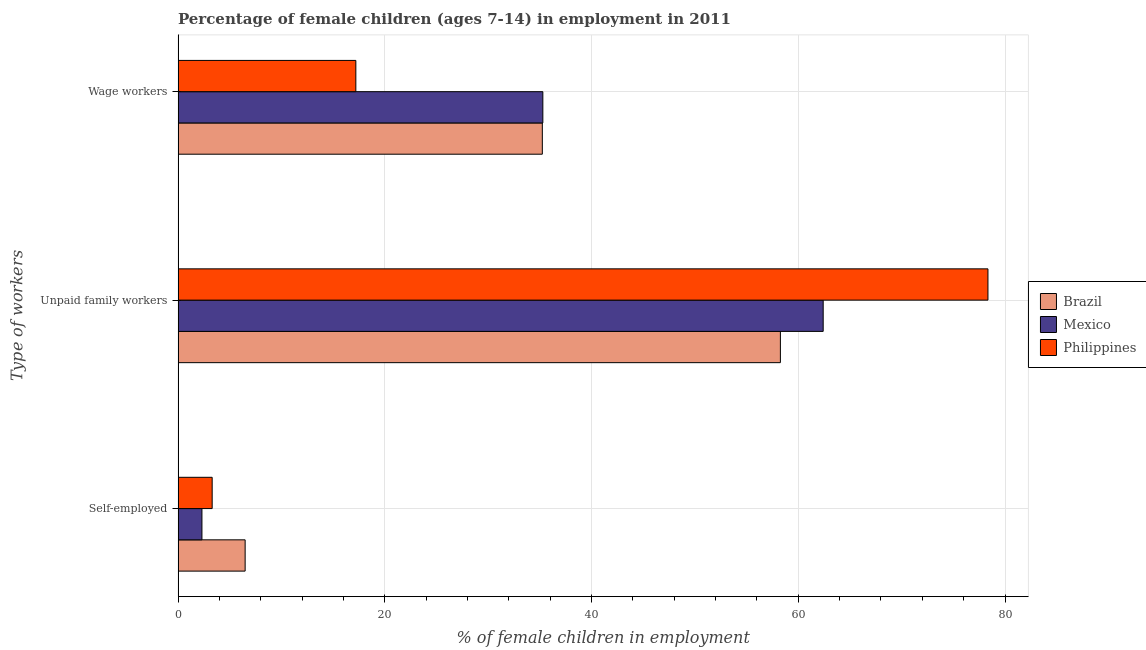How many different coloured bars are there?
Ensure brevity in your answer.  3. How many groups of bars are there?
Provide a short and direct response. 3. How many bars are there on the 1st tick from the top?
Make the answer very short. 3. What is the label of the 2nd group of bars from the top?
Provide a short and direct response. Unpaid family workers. What is the percentage of children employed as unpaid family workers in Philippines?
Offer a very short reply. 78.35. Across all countries, what is the maximum percentage of self employed children?
Provide a succinct answer. 6.49. In which country was the percentage of children employed as wage workers maximum?
Make the answer very short. Mexico. What is the total percentage of children employed as wage workers in the graph?
Offer a very short reply. 87.73. What is the difference between the percentage of children employed as wage workers in Brazil and that in Mexico?
Your answer should be compact. -0.05. What is the difference between the percentage of children employed as wage workers in Philippines and the percentage of self employed children in Brazil?
Your answer should be compact. 10.71. What is the average percentage of children employed as wage workers per country?
Ensure brevity in your answer.  29.24. What is the difference between the percentage of children employed as wage workers and percentage of self employed children in Brazil?
Your answer should be very brief. 28.75. What is the ratio of the percentage of children employed as wage workers in Brazil to that in Philippines?
Offer a terse response. 2.05. Is the difference between the percentage of children employed as wage workers in Philippines and Brazil greater than the difference between the percentage of children employed as unpaid family workers in Philippines and Brazil?
Make the answer very short. No. What is the difference between the highest and the second highest percentage of children employed as unpaid family workers?
Your response must be concise. 15.94. What is the difference between the highest and the lowest percentage of children employed as wage workers?
Provide a short and direct response. 18.09. In how many countries, is the percentage of children employed as unpaid family workers greater than the average percentage of children employed as unpaid family workers taken over all countries?
Your response must be concise. 1. What does the 2nd bar from the top in Self-employed represents?
Provide a succinct answer. Mexico. What does the 2nd bar from the bottom in Self-employed represents?
Provide a succinct answer. Mexico. Are all the bars in the graph horizontal?
Give a very brief answer. Yes. What is the difference between two consecutive major ticks on the X-axis?
Provide a short and direct response. 20. Are the values on the major ticks of X-axis written in scientific E-notation?
Make the answer very short. No. Where does the legend appear in the graph?
Your response must be concise. Center right. How many legend labels are there?
Provide a succinct answer. 3. How are the legend labels stacked?
Give a very brief answer. Vertical. What is the title of the graph?
Give a very brief answer. Percentage of female children (ages 7-14) in employment in 2011. What is the label or title of the X-axis?
Give a very brief answer. % of female children in employment. What is the label or title of the Y-axis?
Provide a succinct answer. Type of workers. What is the % of female children in employment of Brazil in Self-employed?
Offer a terse response. 6.49. What is the % of female children in employment of Mexico in Self-employed?
Give a very brief answer. 2.31. What is the % of female children in employment of Philippines in Self-employed?
Provide a short and direct response. 3.3. What is the % of female children in employment in Brazil in Unpaid family workers?
Make the answer very short. 58.27. What is the % of female children in employment of Mexico in Unpaid family workers?
Make the answer very short. 62.41. What is the % of female children in employment of Philippines in Unpaid family workers?
Make the answer very short. 78.35. What is the % of female children in employment of Brazil in Wage workers?
Your response must be concise. 35.24. What is the % of female children in employment in Mexico in Wage workers?
Your response must be concise. 35.29. What is the % of female children in employment of Philippines in Wage workers?
Your answer should be very brief. 17.2. Across all Type of workers, what is the maximum % of female children in employment in Brazil?
Your answer should be compact. 58.27. Across all Type of workers, what is the maximum % of female children in employment of Mexico?
Your answer should be very brief. 62.41. Across all Type of workers, what is the maximum % of female children in employment of Philippines?
Provide a succinct answer. 78.35. Across all Type of workers, what is the minimum % of female children in employment in Brazil?
Your response must be concise. 6.49. Across all Type of workers, what is the minimum % of female children in employment of Mexico?
Provide a short and direct response. 2.31. Across all Type of workers, what is the minimum % of female children in employment of Philippines?
Provide a short and direct response. 3.3. What is the total % of female children in employment of Brazil in the graph?
Your answer should be compact. 100. What is the total % of female children in employment of Mexico in the graph?
Keep it short and to the point. 100.01. What is the total % of female children in employment in Philippines in the graph?
Your response must be concise. 98.85. What is the difference between the % of female children in employment of Brazil in Self-employed and that in Unpaid family workers?
Offer a terse response. -51.78. What is the difference between the % of female children in employment in Mexico in Self-employed and that in Unpaid family workers?
Your response must be concise. -60.1. What is the difference between the % of female children in employment in Philippines in Self-employed and that in Unpaid family workers?
Keep it short and to the point. -75.05. What is the difference between the % of female children in employment in Brazil in Self-employed and that in Wage workers?
Provide a succinct answer. -28.75. What is the difference between the % of female children in employment of Mexico in Self-employed and that in Wage workers?
Ensure brevity in your answer.  -32.98. What is the difference between the % of female children in employment of Brazil in Unpaid family workers and that in Wage workers?
Offer a terse response. 23.03. What is the difference between the % of female children in employment of Mexico in Unpaid family workers and that in Wage workers?
Ensure brevity in your answer.  27.12. What is the difference between the % of female children in employment of Philippines in Unpaid family workers and that in Wage workers?
Make the answer very short. 61.15. What is the difference between the % of female children in employment of Brazil in Self-employed and the % of female children in employment of Mexico in Unpaid family workers?
Your answer should be very brief. -55.92. What is the difference between the % of female children in employment in Brazil in Self-employed and the % of female children in employment in Philippines in Unpaid family workers?
Ensure brevity in your answer.  -71.86. What is the difference between the % of female children in employment in Mexico in Self-employed and the % of female children in employment in Philippines in Unpaid family workers?
Offer a terse response. -76.04. What is the difference between the % of female children in employment of Brazil in Self-employed and the % of female children in employment of Mexico in Wage workers?
Make the answer very short. -28.8. What is the difference between the % of female children in employment of Brazil in Self-employed and the % of female children in employment of Philippines in Wage workers?
Provide a short and direct response. -10.71. What is the difference between the % of female children in employment of Mexico in Self-employed and the % of female children in employment of Philippines in Wage workers?
Make the answer very short. -14.89. What is the difference between the % of female children in employment of Brazil in Unpaid family workers and the % of female children in employment of Mexico in Wage workers?
Offer a terse response. 22.98. What is the difference between the % of female children in employment in Brazil in Unpaid family workers and the % of female children in employment in Philippines in Wage workers?
Give a very brief answer. 41.07. What is the difference between the % of female children in employment of Mexico in Unpaid family workers and the % of female children in employment of Philippines in Wage workers?
Your answer should be compact. 45.21. What is the average % of female children in employment in Brazil per Type of workers?
Offer a very short reply. 33.33. What is the average % of female children in employment in Mexico per Type of workers?
Provide a succinct answer. 33.34. What is the average % of female children in employment in Philippines per Type of workers?
Your response must be concise. 32.95. What is the difference between the % of female children in employment in Brazil and % of female children in employment in Mexico in Self-employed?
Your response must be concise. 4.18. What is the difference between the % of female children in employment in Brazil and % of female children in employment in Philippines in Self-employed?
Your response must be concise. 3.19. What is the difference between the % of female children in employment of Mexico and % of female children in employment of Philippines in Self-employed?
Your answer should be very brief. -0.99. What is the difference between the % of female children in employment in Brazil and % of female children in employment in Mexico in Unpaid family workers?
Offer a very short reply. -4.14. What is the difference between the % of female children in employment in Brazil and % of female children in employment in Philippines in Unpaid family workers?
Offer a terse response. -20.08. What is the difference between the % of female children in employment of Mexico and % of female children in employment of Philippines in Unpaid family workers?
Give a very brief answer. -15.94. What is the difference between the % of female children in employment in Brazil and % of female children in employment in Philippines in Wage workers?
Your answer should be very brief. 18.04. What is the difference between the % of female children in employment of Mexico and % of female children in employment of Philippines in Wage workers?
Provide a short and direct response. 18.09. What is the ratio of the % of female children in employment of Brazil in Self-employed to that in Unpaid family workers?
Keep it short and to the point. 0.11. What is the ratio of the % of female children in employment in Mexico in Self-employed to that in Unpaid family workers?
Your response must be concise. 0.04. What is the ratio of the % of female children in employment of Philippines in Self-employed to that in Unpaid family workers?
Provide a short and direct response. 0.04. What is the ratio of the % of female children in employment of Brazil in Self-employed to that in Wage workers?
Provide a short and direct response. 0.18. What is the ratio of the % of female children in employment in Mexico in Self-employed to that in Wage workers?
Offer a terse response. 0.07. What is the ratio of the % of female children in employment in Philippines in Self-employed to that in Wage workers?
Offer a terse response. 0.19. What is the ratio of the % of female children in employment in Brazil in Unpaid family workers to that in Wage workers?
Your answer should be very brief. 1.65. What is the ratio of the % of female children in employment of Mexico in Unpaid family workers to that in Wage workers?
Your answer should be compact. 1.77. What is the ratio of the % of female children in employment in Philippines in Unpaid family workers to that in Wage workers?
Give a very brief answer. 4.56. What is the difference between the highest and the second highest % of female children in employment in Brazil?
Keep it short and to the point. 23.03. What is the difference between the highest and the second highest % of female children in employment of Mexico?
Give a very brief answer. 27.12. What is the difference between the highest and the second highest % of female children in employment of Philippines?
Provide a short and direct response. 61.15. What is the difference between the highest and the lowest % of female children in employment in Brazil?
Give a very brief answer. 51.78. What is the difference between the highest and the lowest % of female children in employment in Mexico?
Offer a very short reply. 60.1. What is the difference between the highest and the lowest % of female children in employment of Philippines?
Give a very brief answer. 75.05. 